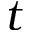<formula> <loc_0><loc_0><loc_500><loc_500>t</formula> 